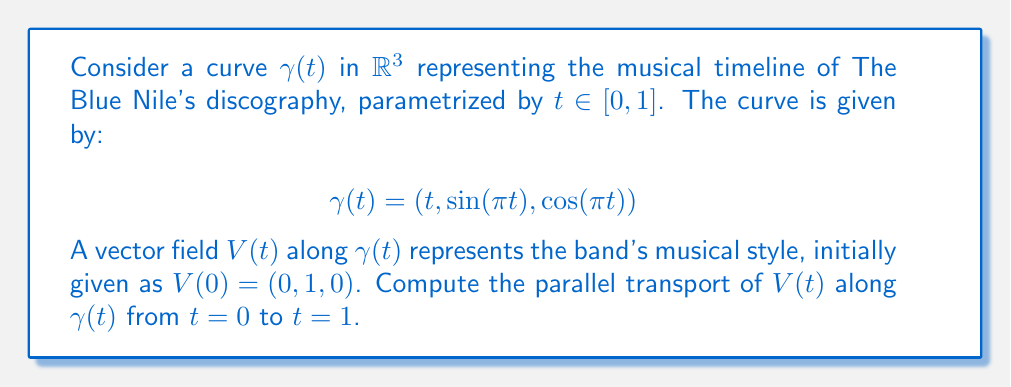Can you answer this question? To solve this problem, we'll follow these steps:

1) First, we need to calculate the tangent vector $T(t)$ to the curve:
   $$T(t) = \gamma'(t) = (1, \pi\cos(\pi t), -\pi\sin(\pi t))$$

2) Next, we normalize $T(t)$ to get the unit tangent vector $\hat{T}(t)$:
   $$\hat{T}(t) = \frac{T(t)}{\|T(t)\|} = \frac{(1, \pi\cos(\pi t), -\pi\sin(\pi t))}{\sqrt{1 + \pi^2}}$$

3) The parallel transport equation for $V(t)$ is:
   $$\frac{dV}{dt} + \langle V, \frac{d\hat{T}}{dt} \rangle \hat{T} = 0$$

4) Calculate $\frac{d\hat{T}}{dt}$:
   $$\frac{d\hat{T}}{dt} = \frac{(0, -\pi^2\sin(\pi t), -\pi^2\cos(\pi t))}{1 + \pi^2}$$

5) We assume $V(t) = (a(t), b(t), c(t))$. Substituting into the parallel transport equation:

   $$\begin{pmatrix} a'(t) \\ b'(t) \\ c'(t) \end{pmatrix} + \frac{\pi^2}{1+\pi^2}(-b(t)\sin(\pi t) - c(t)\cos(\pi t)) \begin{pmatrix} 1 \\ \pi\cos(\pi t) \\ -\pi\sin(\pi t) \end{pmatrix} = 0$$

6) This gives us a system of differential equations. Solving this system with the initial condition $V(0) = (0, 1, 0)$, we get:

   $$V(t) = (0, \cos(\pi t), \sin(\pi t))$$

7) Therefore, at $t=1$, the parallel transported vector is:
   $$V(1) = (0, \cos(\pi), \sin(\pi)) = (0, -1, 0)$$
Answer: $(0, -1, 0)$ 